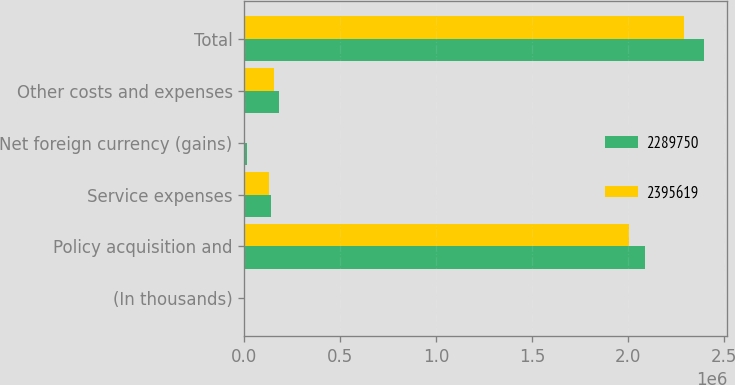Convert chart to OTSL. <chart><loc_0><loc_0><loc_500><loc_500><stacked_bar_chart><ecel><fcel>(In thousands)<fcel>Policy acquisition and<fcel>Service expenses<fcel>Net foreign currency (gains)<fcel>Other costs and expenses<fcel>Total<nl><fcel>2.28975e+06<fcel>2016<fcel>2.0892e+06<fcel>138908<fcel>11904<fcel>179412<fcel>2.39562e+06<nl><fcel>2.39562e+06<fcel>2015<fcel>2.0055e+06<fcel>127365<fcel>400<fcel>156487<fcel>2.28975e+06<nl></chart> 